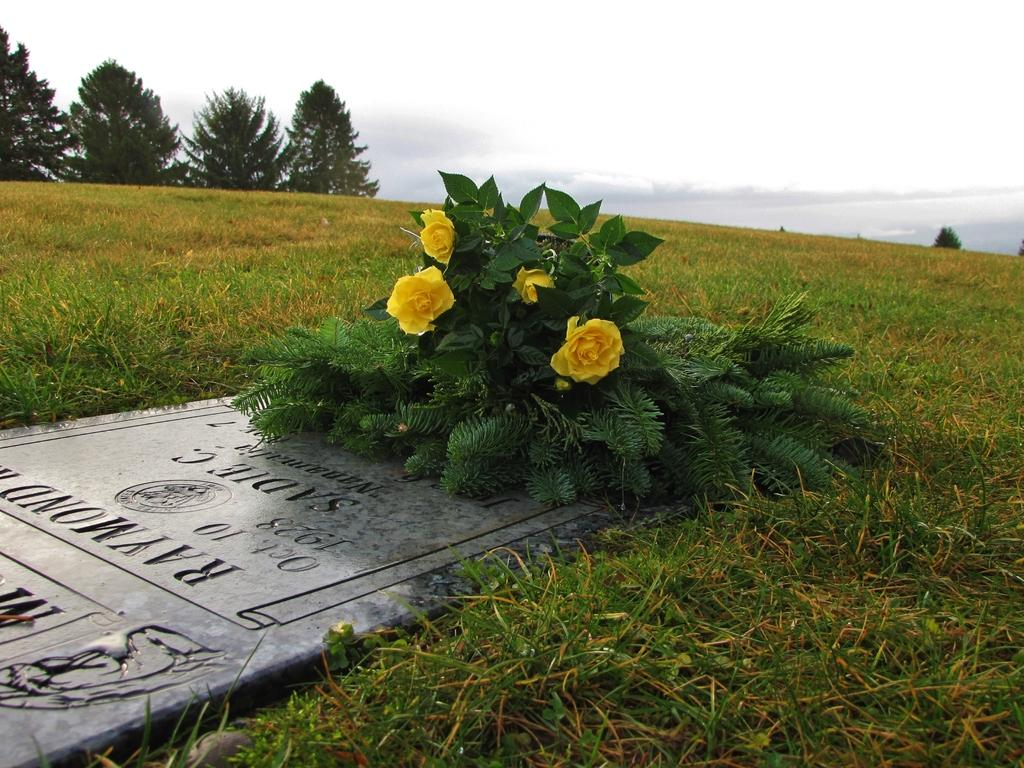What is the main object in the image? There is a stone in the image. What is written or depicted on the stone? There is text on the stone. What is placed on top of the stone? There is a bouquet on the stone. What type of vegetation is visible beside the stone? There is grass beside the stone. What can be seen in the background of the image? Trees and the sky are visible at the top of the image. What type of pan is being used to cook food in the image? There is no pan or cooking activity present in the image; it features a stone with text and a bouquet. What type of quill is being used to write on the stone in the image? There is no quill or writing activity present in the image; the text on the stone is already written. 